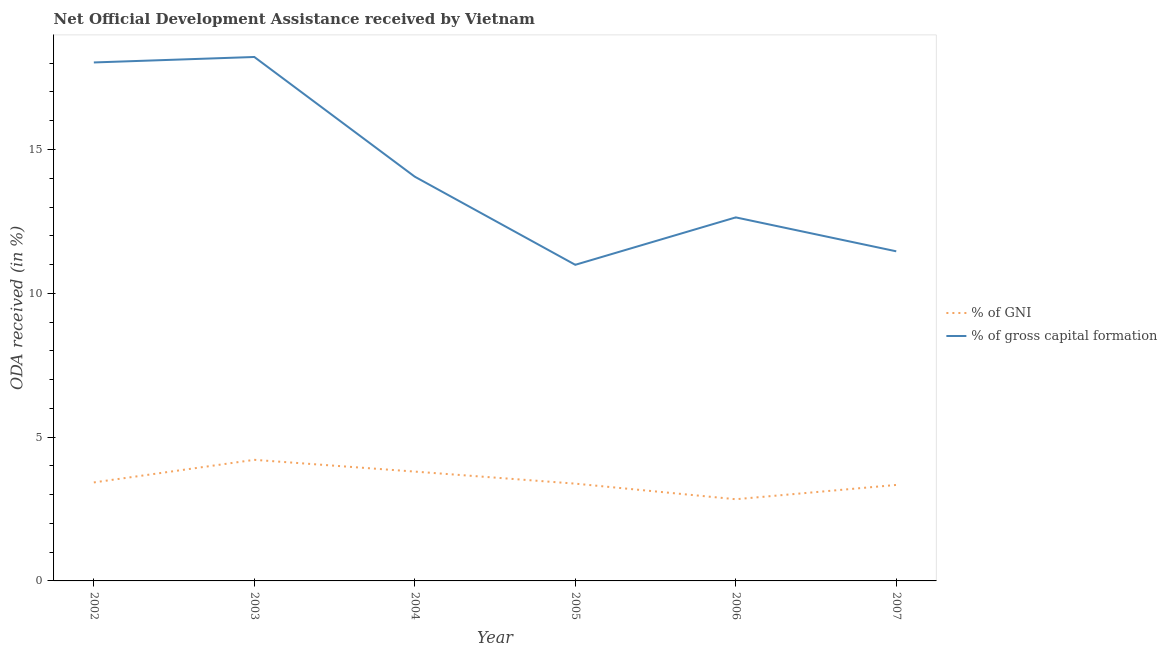How many different coloured lines are there?
Provide a short and direct response. 2. Does the line corresponding to oda received as percentage of gross capital formation intersect with the line corresponding to oda received as percentage of gni?
Offer a terse response. No. What is the oda received as percentage of gni in 2007?
Provide a succinct answer. 3.34. Across all years, what is the maximum oda received as percentage of gni?
Keep it short and to the point. 4.21. Across all years, what is the minimum oda received as percentage of gross capital formation?
Provide a short and direct response. 10.99. In which year was the oda received as percentage of gross capital formation maximum?
Ensure brevity in your answer.  2003. What is the total oda received as percentage of gni in the graph?
Provide a short and direct response. 20.99. What is the difference between the oda received as percentage of gni in 2005 and that in 2006?
Offer a terse response. 0.54. What is the difference between the oda received as percentage of gross capital formation in 2007 and the oda received as percentage of gni in 2002?
Give a very brief answer. 8.04. What is the average oda received as percentage of gni per year?
Make the answer very short. 3.5. In the year 2004, what is the difference between the oda received as percentage of gni and oda received as percentage of gross capital formation?
Give a very brief answer. -10.25. In how many years, is the oda received as percentage of gross capital formation greater than 10 %?
Give a very brief answer. 6. What is the ratio of the oda received as percentage of gni in 2005 to that in 2006?
Provide a short and direct response. 1.19. Is the oda received as percentage of gross capital formation in 2003 less than that in 2006?
Offer a very short reply. No. Is the difference between the oda received as percentage of gross capital formation in 2004 and 2005 greater than the difference between the oda received as percentage of gni in 2004 and 2005?
Your answer should be compact. Yes. What is the difference between the highest and the second highest oda received as percentage of gni?
Make the answer very short. 0.41. What is the difference between the highest and the lowest oda received as percentage of gross capital formation?
Provide a short and direct response. 7.23. Is the sum of the oda received as percentage of gni in 2002 and 2007 greater than the maximum oda received as percentage of gross capital formation across all years?
Your answer should be compact. No. Does the oda received as percentage of gni monotonically increase over the years?
Give a very brief answer. No. Is the oda received as percentage of gni strictly greater than the oda received as percentage of gross capital formation over the years?
Provide a succinct answer. No. How many lines are there?
Make the answer very short. 2. How many years are there in the graph?
Offer a terse response. 6. What is the difference between two consecutive major ticks on the Y-axis?
Provide a succinct answer. 5. Does the graph contain grids?
Provide a succinct answer. No. How are the legend labels stacked?
Give a very brief answer. Vertical. What is the title of the graph?
Provide a short and direct response. Net Official Development Assistance received by Vietnam. What is the label or title of the Y-axis?
Give a very brief answer. ODA received (in %). What is the ODA received (in %) in % of GNI in 2002?
Keep it short and to the point. 3.42. What is the ODA received (in %) in % of gross capital formation in 2002?
Ensure brevity in your answer.  18.03. What is the ODA received (in %) in % of GNI in 2003?
Offer a terse response. 4.21. What is the ODA received (in %) of % of gross capital formation in 2003?
Offer a very short reply. 18.22. What is the ODA received (in %) in % of GNI in 2004?
Your response must be concise. 3.8. What is the ODA received (in %) in % of gross capital formation in 2004?
Provide a short and direct response. 14.05. What is the ODA received (in %) in % of GNI in 2005?
Offer a terse response. 3.38. What is the ODA received (in %) in % of gross capital formation in 2005?
Give a very brief answer. 10.99. What is the ODA received (in %) in % of GNI in 2006?
Your answer should be very brief. 2.84. What is the ODA received (in %) of % of gross capital formation in 2006?
Provide a succinct answer. 12.64. What is the ODA received (in %) of % of GNI in 2007?
Your answer should be compact. 3.34. What is the ODA received (in %) in % of gross capital formation in 2007?
Offer a terse response. 11.46. Across all years, what is the maximum ODA received (in %) in % of GNI?
Keep it short and to the point. 4.21. Across all years, what is the maximum ODA received (in %) in % of gross capital formation?
Provide a short and direct response. 18.22. Across all years, what is the minimum ODA received (in %) in % of GNI?
Provide a succinct answer. 2.84. Across all years, what is the minimum ODA received (in %) of % of gross capital formation?
Your response must be concise. 10.99. What is the total ODA received (in %) in % of GNI in the graph?
Keep it short and to the point. 21. What is the total ODA received (in %) in % of gross capital formation in the graph?
Provide a short and direct response. 85.39. What is the difference between the ODA received (in %) in % of GNI in 2002 and that in 2003?
Keep it short and to the point. -0.79. What is the difference between the ODA received (in %) of % of gross capital formation in 2002 and that in 2003?
Your answer should be very brief. -0.19. What is the difference between the ODA received (in %) in % of GNI in 2002 and that in 2004?
Give a very brief answer. -0.38. What is the difference between the ODA received (in %) of % of gross capital formation in 2002 and that in 2004?
Offer a very short reply. 3.97. What is the difference between the ODA received (in %) in % of GNI in 2002 and that in 2005?
Your response must be concise. 0.04. What is the difference between the ODA received (in %) of % of gross capital formation in 2002 and that in 2005?
Ensure brevity in your answer.  7.04. What is the difference between the ODA received (in %) of % of GNI in 2002 and that in 2006?
Offer a terse response. 0.58. What is the difference between the ODA received (in %) in % of gross capital formation in 2002 and that in 2006?
Provide a succinct answer. 5.39. What is the difference between the ODA received (in %) in % of GNI in 2002 and that in 2007?
Your response must be concise. 0.09. What is the difference between the ODA received (in %) of % of gross capital formation in 2002 and that in 2007?
Make the answer very short. 6.57. What is the difference between the ODA received (in %) of % of GNI in 2003 and that in 2004?
Offer a very short reply. 0.41. What is the difference between the ODA received (in %) in % of gross capital formation in 2003 and that in 2004?
Provide a short and direct response. 4.16. What is the difference between the ODA received (in %) in % of GNI in 2003 and that in 2005?
Your answer should be very brief. 0.83. What is the difference between the ODA received (in %) of % of gross capital formation in 2003 and that in 2005?
Your response must be concise. 7.23. What is the difference between the ODA received (in %) of % of GNI in 2003 and that in 2006?
Give a very brief answer. 1.37. What is the difference between the ODA received (in %) in % of gross capital formation in 2003 and that in 2006?
Give a very brief answer. 5.58. What is the difference between the ODA received (in %) in % of GNI in 2003 and that in 2007?
Ensure brevity in your answer.  0.87. What is the difference between the ODA received (in %) in % of gross capital formation in 2003 and that in 2007?
Offer a very short reply. 6.76. What is the difference between the ODA received (in %) in % of GNI in 2004 and that in 2005?
Make the answer very short. 0.42. What is the difference between the ODA received (in %) of % of gross capital formation in 2004 and that in 2005?
Make the answer very short. 3.06. What is the difference between the ODA received (in %) of % of gross capital formation in 2004 and that in 2006?
Your response must be concise. 1.42. What is the difference between the ODA received (in %) of % of GNI in 2004 and that in 2007?
Make the answer very short. 0.46. What is the difference between the ODA received (in %) of % of gross capital formation in 2004 and that in 2007?
Offer a terse response. 2.59. What is the difference between the ODA received (in %) of % of GNI in 2005 and that in 2006?
Make the answer very short. 0.54. What is the difference between the ODA received (in %) in % of gross capital formation in 2005 and that in 2006?
Provide a short and direct response. -1.65. What is the difference between the ODA received (in %) in % of GNI in 2005 and that in 2007?
Ensure brevity in your answer.  0.05. What is the difference between the ODA received (in %) in % of gross capital formation in 2005 and that in 2007?
Keep it short and to the point. -0.47. What is the difference between the ODA received (in %) of % of GNI in 2006 and that in 2007?
Provide a succinct answer. -0.5. What is the difference between the ODA received (in %) in % of gross capital formation in 2006 and that in 2007?
Make the answer very short. 1.18. What is the difference between the ODA received (in %) of % of GNI in 2002 and the ODA received (in %) of % of gross capital formation in 2003?
Give a very brief answer. -14.79. What is the difference between the ODA received (in %) in % of GNI in 2002 and the ODA received (in %) in % of gross capital formation in 2004?
Give a very brief answer. -10.63. What is the difference between the ODA received (in %) in % of GNI in 2002 and the ODA received (in %) in % of gross capital formation in 2005?
Provide a succinct answer. -7.57. What is the difference between the ODA received (in %) in % of GNI in 2002 and the ODA received (in %) in % of gross capital formation in 2006?
Give a very brief answer. -9.21. What is the difference between the ODA received (in %) in % of GNI in 2002 and the ODA received (in %) in % of gross capital formation in 2007?
Your answer should be compact. -8.04. What is the difference between the ODA received (in %) in % of GNI in 2003 and the ODA received (in %) in % of gross capital formation in 2004?
Offer a terse response. -9.84. What is the difference between the ODA received (in %) of % of GNI in 2003 and the ODA received (in %) of % of gross capital formation in 2005?
Provide a succinct answer. -6.78. What is the difference between the ODA received (in %) in % of GNI in 2003 and the ODA received (in %) in % of gross capital formation in 2006?
Offer a very short reply. -8.43. What is the difference between the ODA received (in %) in % of GNI in 2003 and the ODA received (in %) in % of gross capital formation in 2007?
Make the answer very short. -7.25. What is the difference between the ODA received (in %) in % of GNI in 2004 and the ODA received (in %) in % of gross capital formation in 2005?
Your answer should be very brief. -7.19. What is the difference between the ODA received (in %) of % of GNI in 2004 and the ODA received (in %) of % of gross capital formation in 2006?
Offer a very short reply. -8.84. What is the difference between the ODA received (in %) of % of GNI in 2004 and the ODA received (in %) of % of gross capital formation in 2007?
Provide a succinct answer. -7.66. What is the difference between the ODA received (in %) of % of GNI in 2005 and the ODA received (in %) of % of gross capital formation in 2006?
Provide a succinct answer. -9.26. What is the difference between the ODA received (in %) of % of GNI in 2005 and the ODA received (in %) of % of gross capital formation in 2007?
Ensure brevity in your answer.  -8.08. What is the difference between the ODA received (in %) in % of GNI in 2006 and the ODA received (in %) in % of gross capital formation in 2007?
Ensure brevity in your answer.  -8.62. What is the average ODA received (in %) in % of GNI per year?
Keep it short and to the point. 3.5. What is the average ODA received (in %) of % of gross capital formation per year?
Offer a terse response. 14.23. In the year 2002, what is the difference between the ODA received (in %) of % of GNI and ODA received (in %) of % of gross capital formation?
Your answer should be very brief. -14.6. In the year 2003, what is the difference between the ODA received (in %) of % of GNI and ODA received (in %) of % of gross capital formation?
Provide a short and direct response. -14.01. In the year 2004, what is the difference between the ODA received (in %) in % of GNI and ODA received (in %) in % of gross capital formation?
Give a very brief answer. -10.25. In the year 2005, what is the difference between the ODA received (in %) of % of GNI and ODA received (in %) of % of gross capital formation?
Offer a terse response. -7.61. In the year 2006, what is the difference between the ODA received (in %) in % of GNI and ODA received (in %) in % of gross capital formation?
Provide a succinct answer. -9.8. In the year 2007, what is the difference between the ODA received (in %) in % of GNI and ODA received (in %) in % of gross capital formation?
Offer a terse response. -8.12. What is the ratio of the ODA received (in %) of % of GNI in 2002 to that in 2003?
Offer a very short reply. 0.81. What is the ratio of the ODA received (in %) of % of GNI in 2002 to that in 2004?
Give a very brief answer. 0.9. What is the ratio of the ODA received (in %) of % of gross capital formation in 2002 to that in 2004?
Your answer should be very brief. 1.28. What is the ratio of the ODA received (in %) of % of GNI in 2002 to that in 2005?
Provide a short and direct response. 1.01. What is the ratio of the ODA received (in %) of % of gross capital formation in 2002 to that in 2005?
Keep it short and to the point. 1.64. What is the ratio of the ODA received (in %) in % of GNI in 2002 to that in 2006?
Your answer should be compact. 1.21. What is the ratio of the ODA received (in %) of % of gross capital formation in 2002 to that in 2006?
Offer a very short reply. 1.43. What is the ratio of the ODA received (in %) of % of GNI in 2002 to that in 2007?
Your response must be concise. 1.03. What is the ratio of the ODA received (in %) of % of gross capital formation in 2002 to that in 2007?
Provide a succinct answer. 1.57. What is the ratio of the ODA received (in %) in % of GNI in 2003 to that in 2004?
Offer a terse response. 1.11. What is the ratio of the ODA received (in %) in % of gross capital formation in 2003 to that in 2004?
Your response must be concise. 1.3. What is the ratio of the ODA received (in %) of % of GNI in 2003 to that in 2005?
Make the answer very short. 1.24. What is the ratio of the ODA received (in %) of % of gross capital formation in 2003 to that in 2005?
Your answer should be very brief. 1.66. What is the ratio of the ODA received (in %) in % of GNI in 2003 to that in 2006?
Provide a succinct answer. 1.48. What is the ratio of the ODA received (in %) of % of gross capital formation in 2003 to that in 2006?
Make the answer very short. 1.44. What is the ratio of the ODA received (in %) in % of GNI in 2003 to that in 2007?
Give a very brief answer. 1.26. What is the ratio of the ODA received (in %) of % of gross capital formation in 2003 to that in 2007?
Ensure brevity in your answer.  1.59. What is the ratio of the ODA received (in %) in % of GNI in 2004 to that in 2005?
Your answer should be compact. 1.12. What is the ratio of the ODA received (in %) in % of gross capital formation in 2004 to that in 2005?
Give a very brief answer. 1.28. What is the ratio of the ODA received (in %) in % of GNI in 2004 to that in 2006?
Provide a succinct answer. 1.34. What is the ratio of the ODA received (in %) of % of gross capital formation in 2004 to that in 2006?
Your answer should be very brief. 1.11. What is the ratio of the ODA received (in %) of % of GNI in 2004 to that in 2007?
Offer a terse response. 1.14. What is the ratio of the ODA received (in %) in % of gross capital formation in 2004 to that in 2007?
Provide a succinct answer. 1.23. What is the ratio of the ODA received (in %) of % of GNI in 2005 to that in 2006?
Provide a succinct answer. 1.19. What is the ratio of the ODA received (in %) in % of gross capital formation in 2005 to that in 2006?
Keep it short and to the point. 0.87. What is the ratio of the ODA received (in %) in % of GNI in 2005 to that in 2007?
Your response must be concise. 1.01. What is the ratio of the ODA received (in %) of % of GNI in 2006 to that in 2007?
Your response must be concise. 0.85. What is the ratio of the ODA received (in %) in % of gross capital formation in 2006 to that in 2007?
Your answer should be very brief. 1.1. What is the difference between the highest and the second highest ODA received (in %) of % of GNI?
Provide a short and direct response. 0.41. What is the difference between the highest and the second highest ODA received (in %) in % of gross capital formation?
Provide a succinct answer. 0.19. What is the difference between the highest and the lowest ODA received (in %) of % of GNI?
Offer a terse response. 1.37. What is the difference between the highest and the lowest ODA received (in %) in % of gross capital formation?
Keep it short and to the point. 7.23. 